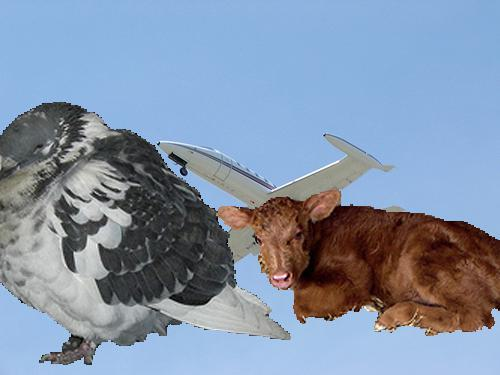Is there a aeroplane in the image? Yes 